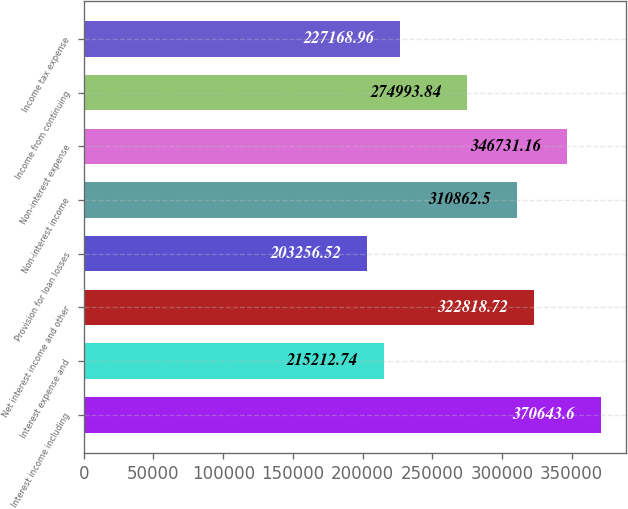<chart> <loc_0><loc_0><loc_500><loc_500><bar_chart><fcel>Interest income including<fcel>Interest expense and<fcel>Net interest income and other<fcel>Provision for loan losses<fcel>Non-interest income<fcel>Non-interest expense<fcel>Income from continuing<fcel>Income tax expense<nl><fcel>370644<fcel>215213<fcel>322819<fcel>203257<fcel>310862<fcel>346731<fcel>274994<fcel>227169<nl></chart> 